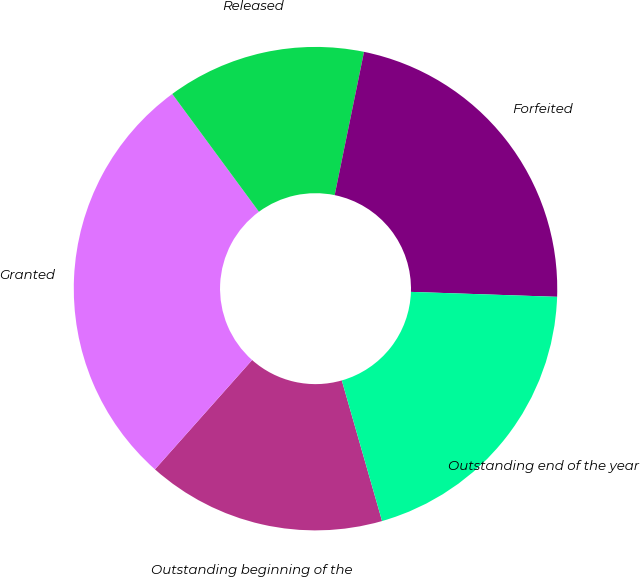Convert chart to OTSL. <chart><loc_0><loc_0><loc_500><loc_500><pie_chart><fcel>Outstanding beginning of the<fcel>Granted<fcel>Released<fcel>Forfeited<fcel>Outstanding end of the year<nl><fcel>16.0%<fcel>28.34%<fcel>13.31%<fcel>22.32%<fcel>20.02%<nl></chart> 